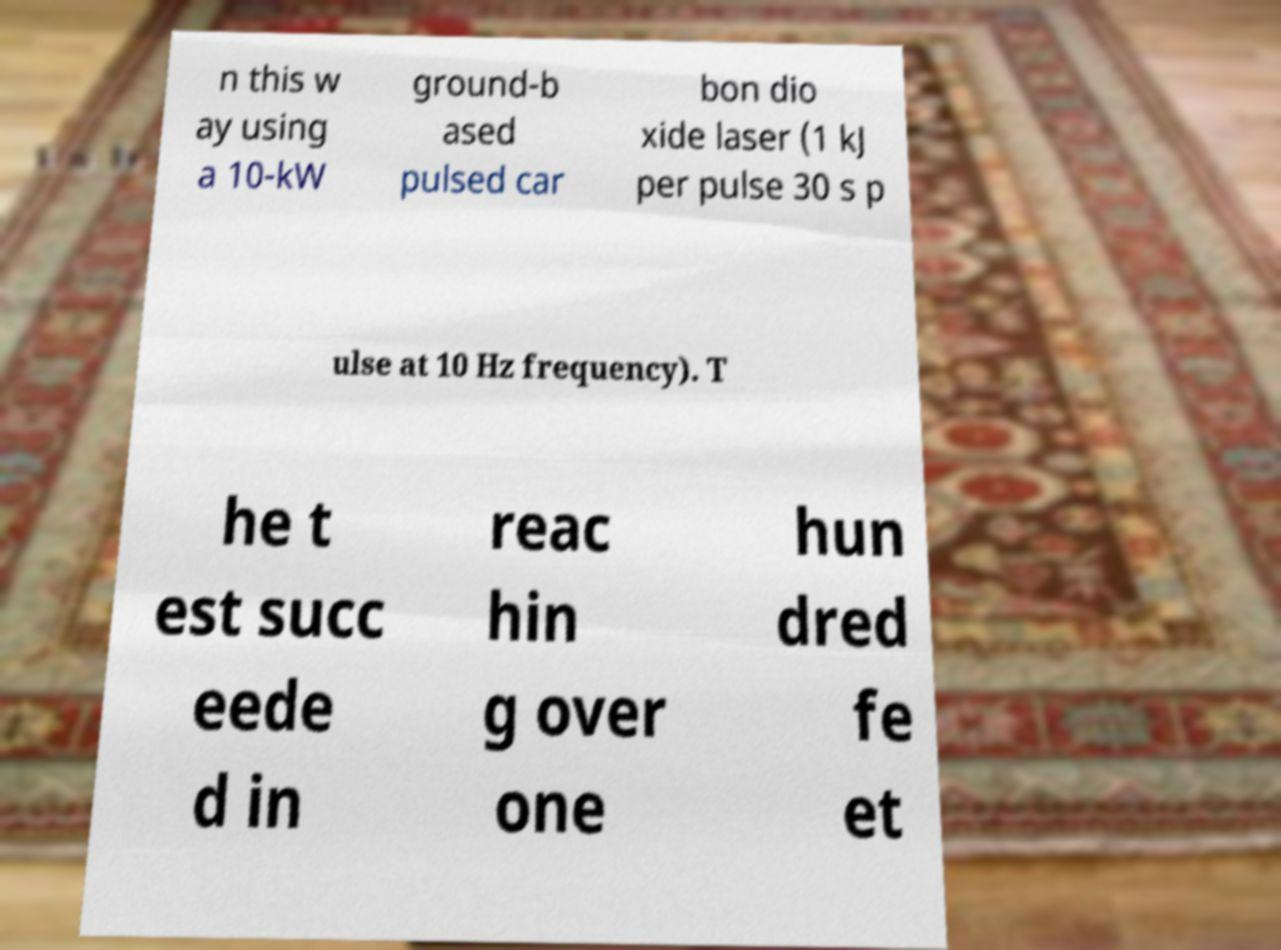There's text embedded in this image that I need extracted. Can you transcribe it verbatim? n this w ay using a 10-kW ground-b ased pulsed car bon dio xide laser (1 kJ per pulse 30 s p ulse at 10 Hz frequency). T he t est succ eede d in reac hin g over one hun dred fe et 